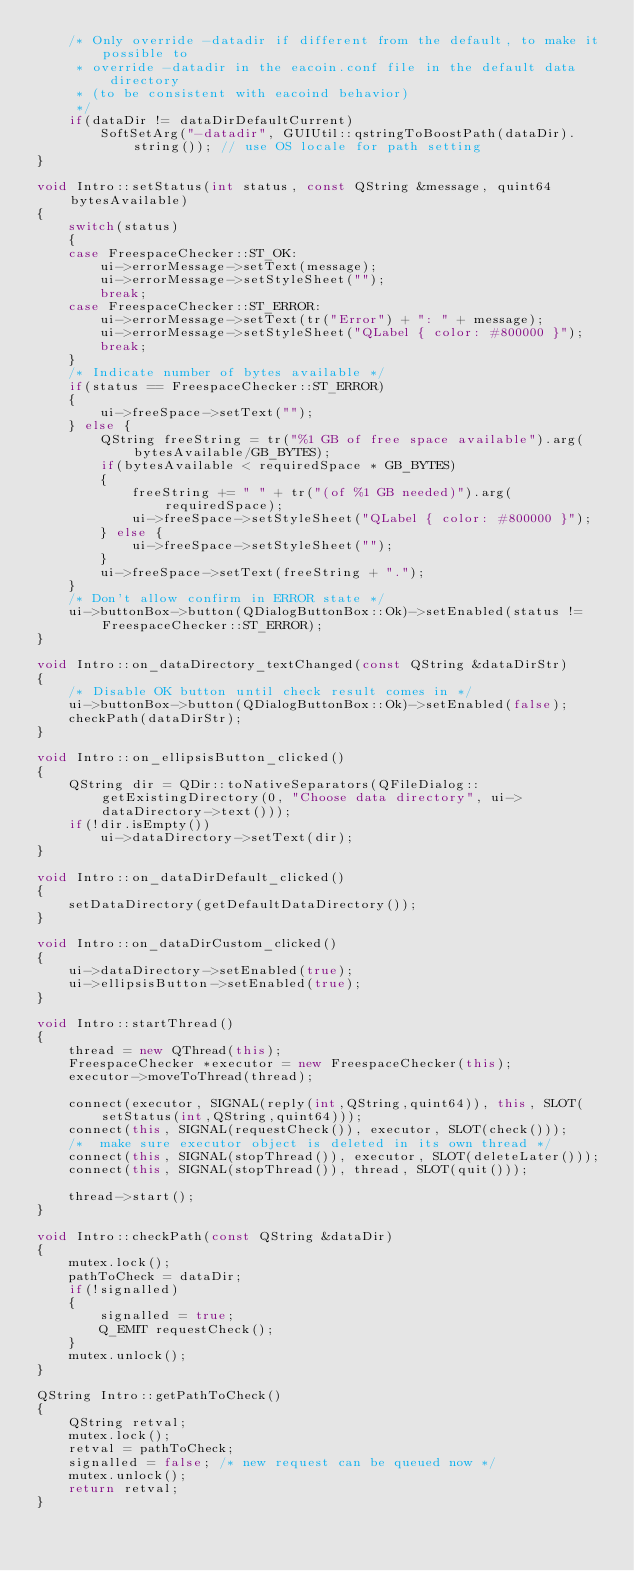Convert code to text. <code><loc_0><loc_0><loc_500><loc_500><_C++_>    /* Only override -datadir if different from the default, to make it possible to
     * override -datadir in the eacoin.conf file in the default data directory
     * (to be consistent with eacoind behavior)
     */
    if(dataDir != dataDirDefaultCurrent)
        SoftSetArg("-datadir", GUIUtil::qstringToBoostPath(dataDir).string()); // use OS locale for path setting
}

void Intro::setStatus(int status, const QString &message, quint64 bytesAvailable)
{
    switch(status)
    {
    case FreespaceChecker::ST_OK:
        ui->errorMessage->setText(message);
        ui->errorMessage->setStyleSheet("");
        break;
    case FreespaceChecker::ST_ERROR:
        ui->errorMessage->setText(tr("Error") + ": " + message);
        ui->errorMessage->setStyleSheet("QLabel { color: #800000 }");
        break;
    }
    /* Indicate number of bytes available */
    if(status == FreespaceChecker::ST_ERROR)
    {
        ui->freeSpace->setText("");
    } else {
        QString freeString = tr("%1 GB of free space available").arg(bytesAvailable/GB_BYTES);
        if(bytesAvailable < requiredSpace * GB_BYTES)
        {
            freeString += " " + tr("(of %1 GB needed)").arg(requiredSpace);
            ui->freeSpace->setStyleSheet("QLabel { color: #800000 }");
        } else {
            ui->freeSpace->setStyleSheet("");
        }
        ui->freeSpace->setText(freeString + ".");
    }
    /* Don't allow confirm in ERROR state */
    ui->buttonBox->button(QDialogButtonBox::Ok)->setEnabled(status != FreespaceChecker::ST_ERROR);
}

void Intro::on_dataDirectory_textChanged(const QString &dataDirStr)
{
    /* Disable OK button until check result comes in */
    ui->buttonBox->button(QDialogButtonBox::Ok)->setEnabled(false);
    checkPath(dataDirStr);
}

void Intro::on_ellipsisButton_clicked()
{
    QString dir = QDir::toNativeSeparators(QFileDialog::getExistingDirectory(0, "Choose data directory", ui->dataDirectory->text()));
    if(!dir.isEmpty())
        ui->dataDirectory->setText(dir);
}

void Intro::on_dataDirDefault_clicked()
{
    setDataDirectory(getDefaultDataDirectory());
}

void Intro::on_dataDirCustom_clicked()
{
    ui->dataDirectory->setEnabled(true);
    ui->ellipsisButton->setEnabled(true);
}

void Intro::startThread()
{
    thread = new QThread(this);
    FreespaceChecker *executor = new FreespaceChecker(this);
    executor->moveToThread(thread);

    connect(executor, SIGNAL(reply(int,QString,quint64)), this, SLOT(setStatus(int,QString,quint64)));
    connect(this, SIGNAL(requestCheck()), executor, SLOT(check()));
    /*  make sure executor object is deleted in its own thread */
    connect(this, SIGNAL(stopThread()), executor, SLOT(deleteLater()));
    connect(this, SIGNAL(stopThread()), thread, SLOT(quit()));

    thread->start();
}

void Intro::checkPath(const QString &dataDir)
{
    mutex.lock();
    pathToCheck = dataDir;
    if(!signalled)
    {
        signalled = true;
        Q_EMIT requestCheck();
    }
    mutex.unlock();
}

QString Intro::getPathToCheck()
{
    QString retval;
    mutex.lock();
    retval = pathToCheck;
    signalled = false; /* new request can be queued now */
    mutex.unlock();
    return retval;
}
</code> 